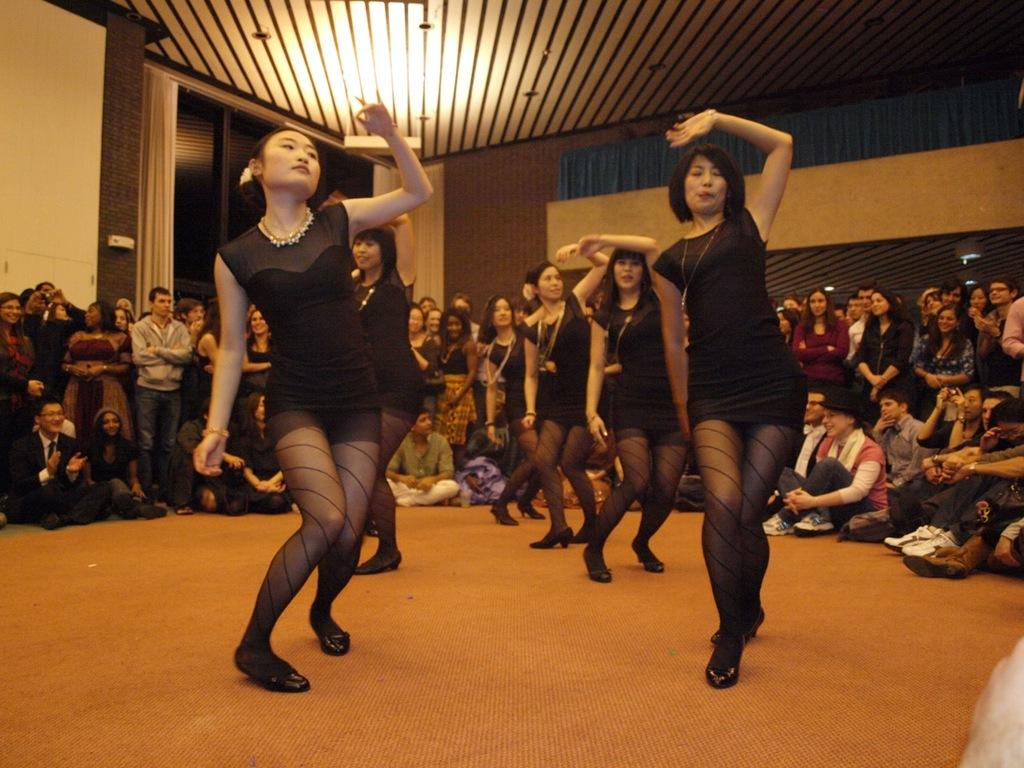How many people are present in the image? There are many people in the image. What are some of the positions of the people in the image? Some people are sitting, and some people are standing. Can you describe the people in the middle of the image? The people in the middle of the image are wearing black dresses. What are the people in black dresses doing? These people in black dresses are dancing. What type of brake can be seen in the image? There is no brake present in the image. What are the people in the image writing on? There is no writing activity depicted in the image. 